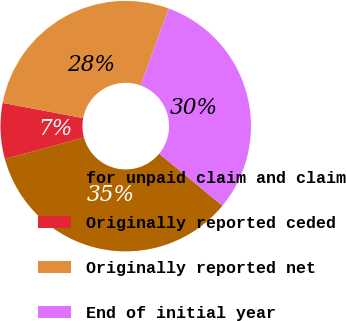<chart> <loc_0><loc_0><loc_500><loc_500><pie_chart><fcel>for unpaid claim and claim<fcel>Originally reported ceded<fcel>Originally reported net<fcel>End of initial year<nl><fcel>34.81%<fcel>7.2%<fcel>27.61%<fcel>30.37%<nl></chart> 